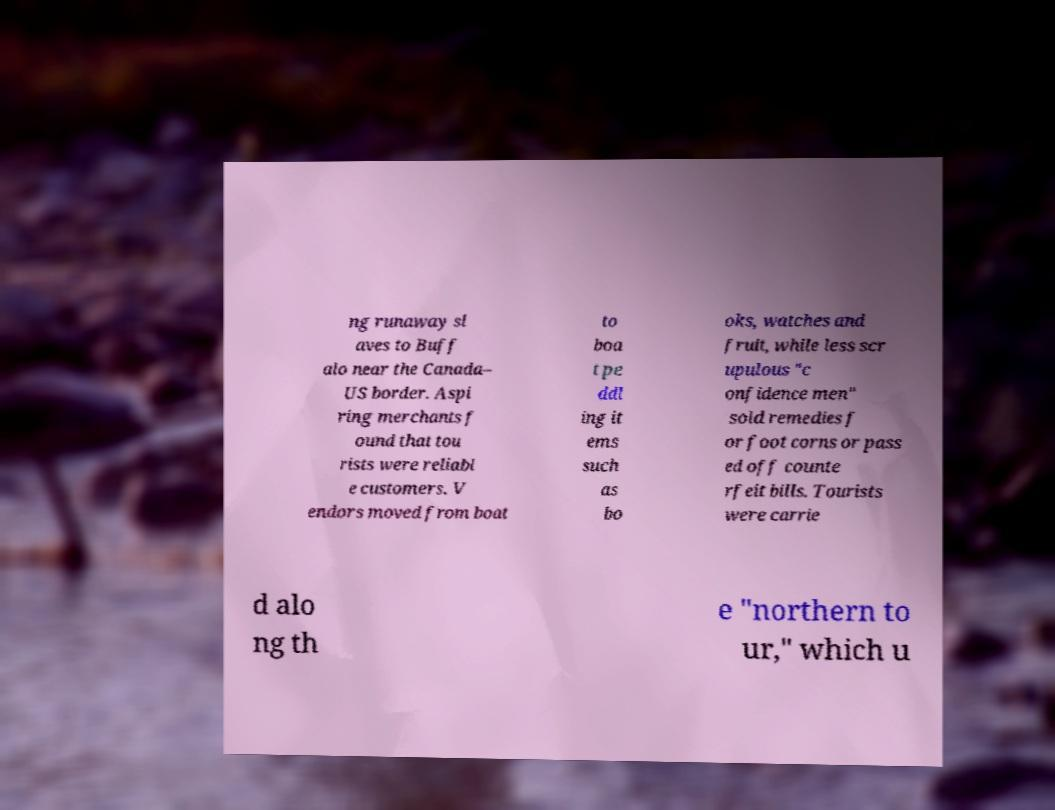Can you read and provide the text displayed in the image?This photo seems to have some interesting text. Can you extract and type it out for me? ng runaway sl aves to Buff alo near the Canada– US border. Aspi ring merchants f ound that tou rists were reliabl e customers. V endors moved from boat to boa t pe ddl ing it ems such as bo oks, watches and fruit, while less scr upulous "c onfidence men" sold remedies f or foot corns or pass ed off counte rfeit bills. Tourists were carrie d alo ng th e "northern to ur," which u 